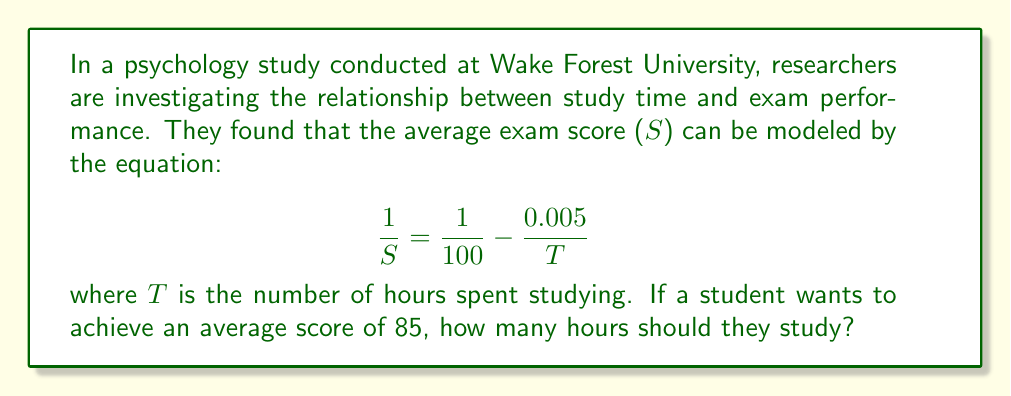What is the answer to this math problem? Let's solve this step-by-step:

1) We start with the given equation:
   $$\frac{1}{S} = \frac{1}{100} - \frac{0.005}{T}$$

2) We want to find T when S = 85. Let's substitute S with 85:
   $$\frac{1}{85} = \frac{1}{100} - \frac{0.005}{T}$$

3) Now, let's solve for T:
   First, subtract $\frac{1}{100}$ from both sides:
   $$\frac{1}{85} - \frac{1}{100} = - \frac{0.005}{T}$$

4) Simplify the left side:
   $$\frac{100-85}{8500} = - \frac{0.005}{T}$$
   $$\frac{15}{8500} = - \frac{0.005}{T}$$

5) Multiply both sides by -1:
   $$-\frac{15}{8500} = \frac{0.005}{T}$$

6) Now, multiply both sides by T:
   $$-\frac{15T}{8500} = 0.005$$

7) Multiply both sides by 8500:
   $$-15T = 42.5$$

8) Divide both sides by -15:
   $$T = \frac{42.5}{15} = 2.833333...$$

Therefore, the student should study approximately 2.83 hours to achieve an average score of 85.
Answer: 2.83 hours 